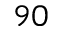Convert formula to latex. <formula><loc_0><loc_0><loc_500><loc_500>^ { 9 0 }</formula> 